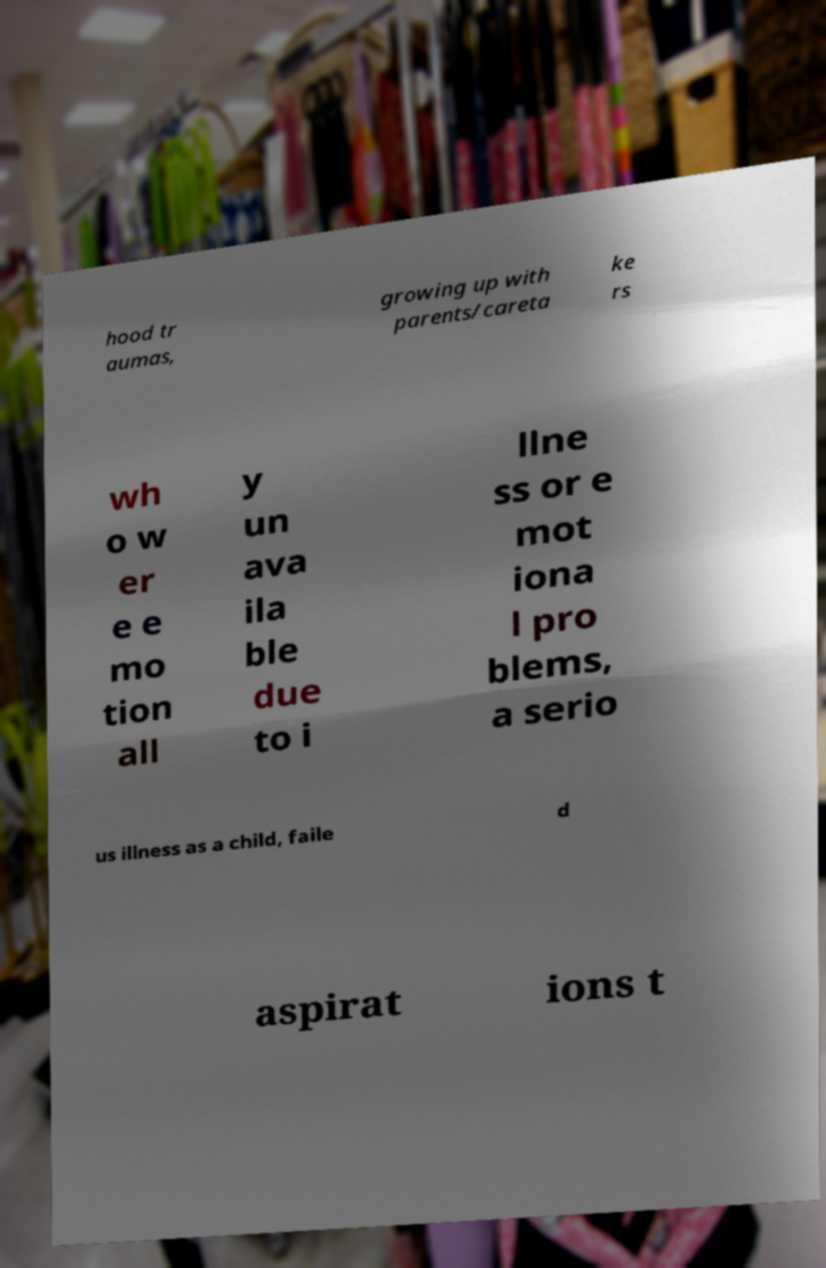Could you extract and type out the text from this image? hood tr aumas, growing up with parents/careta ke rs wh o w er e e mo tion all y un ava ila ble due to i llne ss or e mot iona l pro blems, a serio us illness as a child, faile d aspirat ions t 